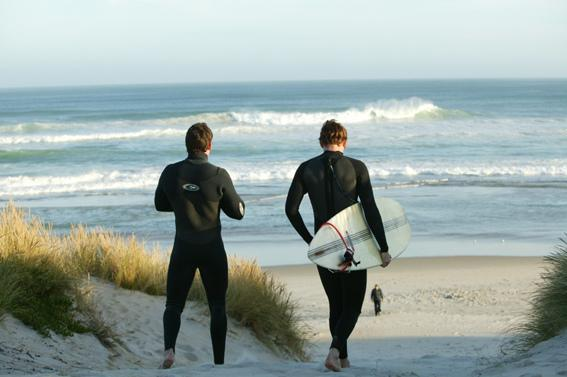Why do they have black suits on? Please explain your reasoning. stay warm. The people are going to surf in the cold water. 